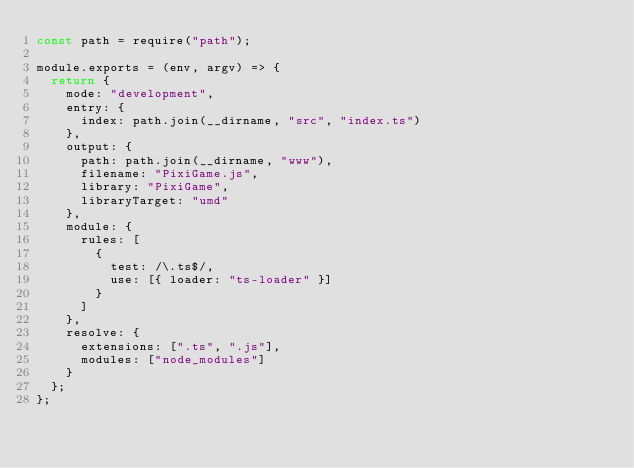<code> <loc_0><loc_0><loc_500><loc_500><_JavaScript_>const path = require("path");

module.exports = (env, argv) => {
  return {
    mode: "development",
    entry: {
      index: path.join(__dirname, "src", "index.ts")
    },
    output: {
      path: path.join(__dirname, "www"),
      filename: "PixiGame.js",
      library: "PixiGame",
      libraryTarget: "umd"
    },
    module: {
      rules: [
        {
          test: /\.ts$/,
          use: [{ loader: "ts-loader" }]
        }
      ]
    },
    resolve: {
      extensions: [".ts", ".js"],
      modules: ["node_modules"]
    }
  };
};
</code> 